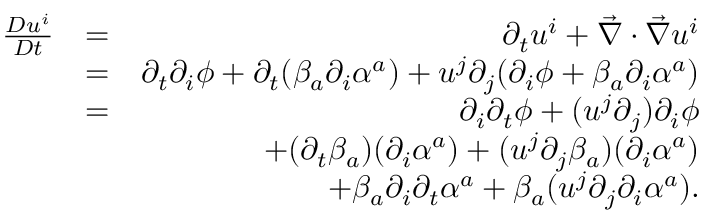Convert formula to latex. <formula><loc_0><loc_0><loc_500><loc_500>\begin{array} { r l r } { \frac { D u ^ { i } } { D t } } & { = } & { \partial _ { t } u ^ { i } + \vec { \nabla } \cdot \vec { \nabla } u ^ { i } } \\ & { = } & { \partial _ { t } \partial _ { i } \phi + \partial _ { t } ( \beta _ { a } \partial _ { i } \alpha ^ { a } ) + u ^ { j } \partial _ { j } ( \partial _ { i } \phi + \beta _ { a } \partial _ { i } \alpha ^ { a } ) } \\ & { = } & { \partial _ { i } \partial _ { t } \phi + ( u ^ { j } \partial _ { j } ) \partial _ { i } \phi } \\ & { + ( \partial _ { t } \beta _ { a } ) ( \partial _ { i } \alpha ^ { a } ) + ( u ^ { j } \partial _ { j } \beta _ { a } ) ( \partial _ { i } \alpha ^ { a } ) } \\ & { + \beta _ { a } \partial _ { i } \partial _ { t } \alpha ^ { a } + \beta _ { a } ( u ^ { j } \partial _ { j } \partial _ { i } \alpha ^ { a } ) . } \end{array}</formula> 